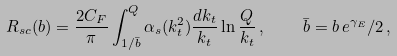Convert formula to latex. <formula><loc_0><loc_0><loc_500><loc_500>R _ { s c } ( b ) = \frac { 2 C _ { F } } { \pi } \int _ { 1 / \bar { b } } ^ { Q } \alpha _ { s } ( k _ { t } ^ { 2 } ) \frac { d k _ { t } } { k _ { t } } \ln \frac { Q } { k _ { t } } \, , \quad \bar { b } = b \, e ^ { \gamma _ { E } } / 2 \, ,</formula> 